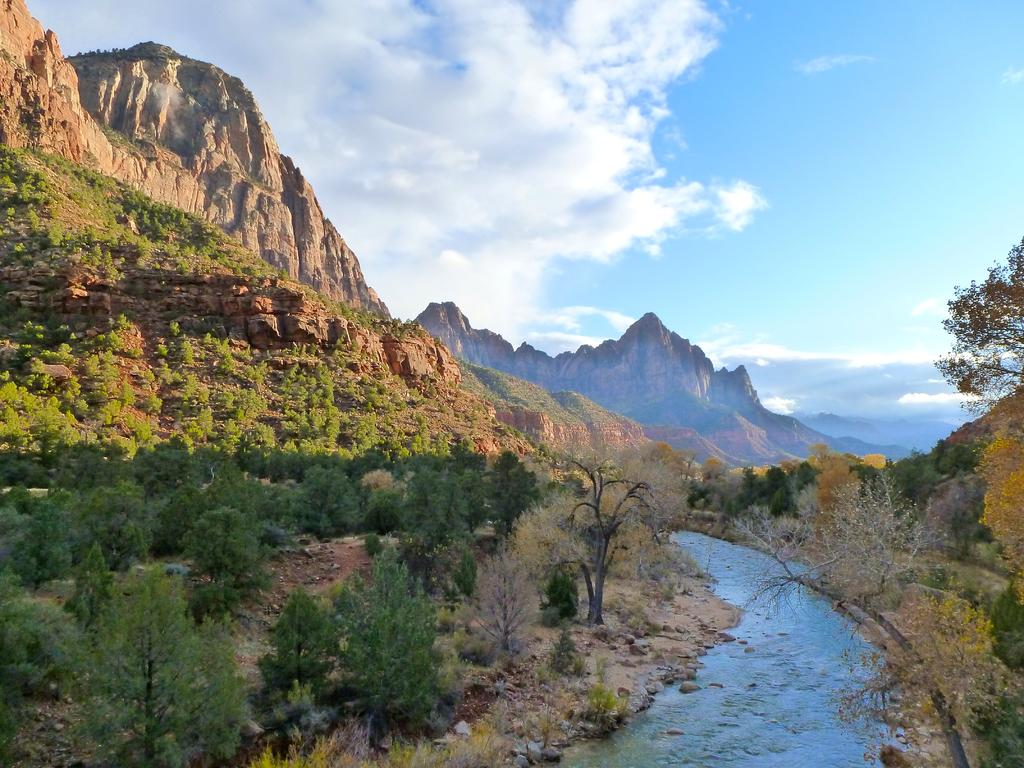What can be seen in the sky in the image? The sky is visible in the image, and clouds are present. What type of terrain is depicted in the image? There are hills in the image, along with trees and rocks. Is there any body of water present in the image? Yes, a river is present in the image. What time of day is it in the image, based on the appearance of the toes? There are no toes visible in the image, so it is not possible to determine the time of day based on them. 